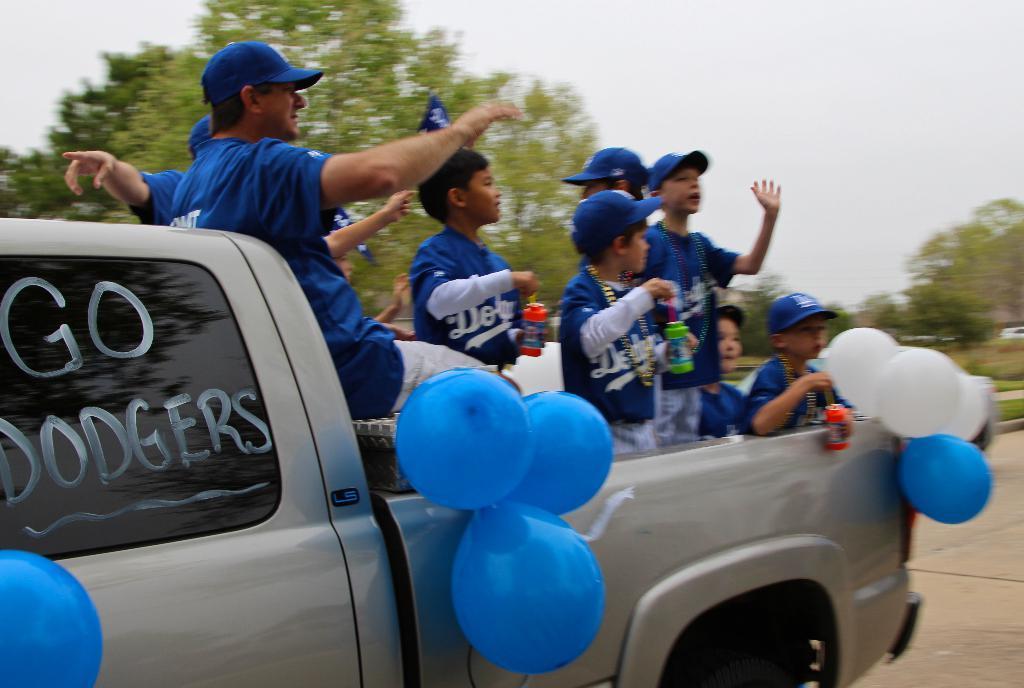How would you summarize this image in a sentence or two? In this image we can see a vehicle. In the vehicle there are few persons. On the vehicle we can see balloons and text. Behind the vehicle we can see trees. At the top we can see the sky. On the glass of the vehicle we can see the reflection of a tree. 